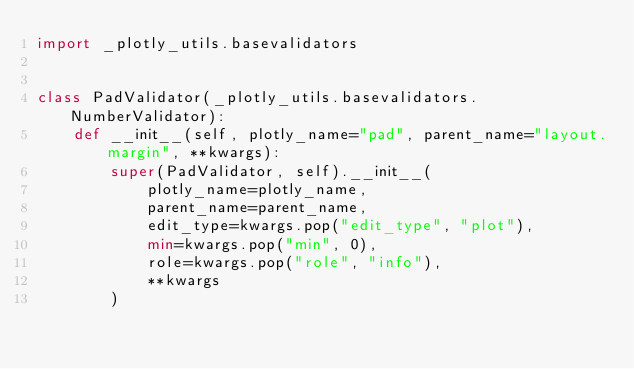Convert code to text. <code><loc_0><loc_0><loc_500><loc_500><_Python_>import _plotly_utils.basevalidators


class PadValidator(_plotly_utils.basevalidators.NumberValidator):
    def __init__(self, plotly_name="pad", parent_name="layout.margin", **kwargs):
        super(PadValidator, self).__init__(
            plotly_name=plotly_name,
            parent_name=parent_name,
            edit_type=kwargs.pop("edit_type", "plot"),
            min=kwargs.pop("min", 0),
            role=kwargs.pop("role", "info"),
            **kwargs
        )
</code> 